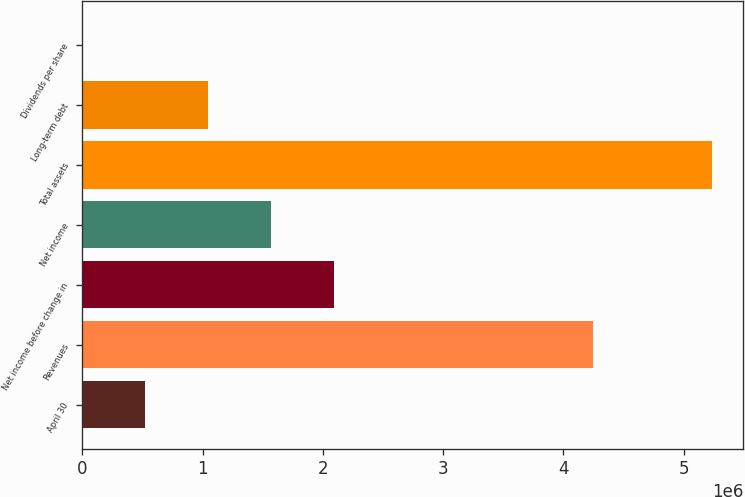Convert chart to OTSL. <chart><loc_0><loc_0><loc_500><loc_500><bar_chart><fcel>April 30<fcel>Revenues<fcel>Net income before change in<fcel>Net income<fcel>Total assets<fcel>Long-term debt<fcel>Dividends per share<nl><fcel>523383<fcel>4.24788e+06<fcel>2.09353e+06<fcel>1.57015e+06<fcel>5.23383e+06<fcel>1.04677e+06<fcel>0.39<nl></chart> 